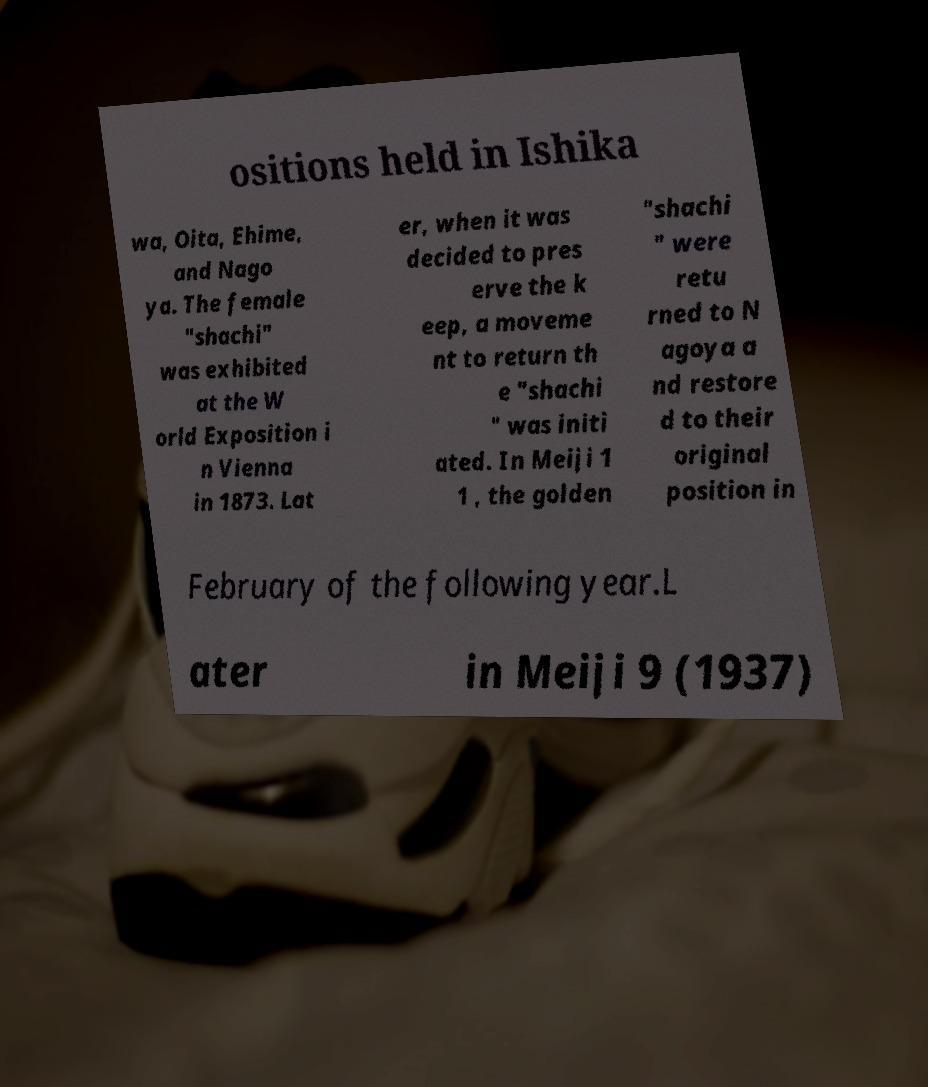For documentation purposes, I need the text within this image transcribed. Could you provide that? ositions held in Ishika wa, Oita, Ehime, and Nago ya. The female "shachi" was exhibited at the W orld Exposition i n Vienna in 1873. Lat er, when it was decided to pres erve the k eep, a moveme nt to return th e "shachi " was initi ated. In Meiji 1 1 , the golden "shachi " were retu rned to N agoya a nd restore d to their original position in February of the following year.L ater in Meiji 9 (1937) 